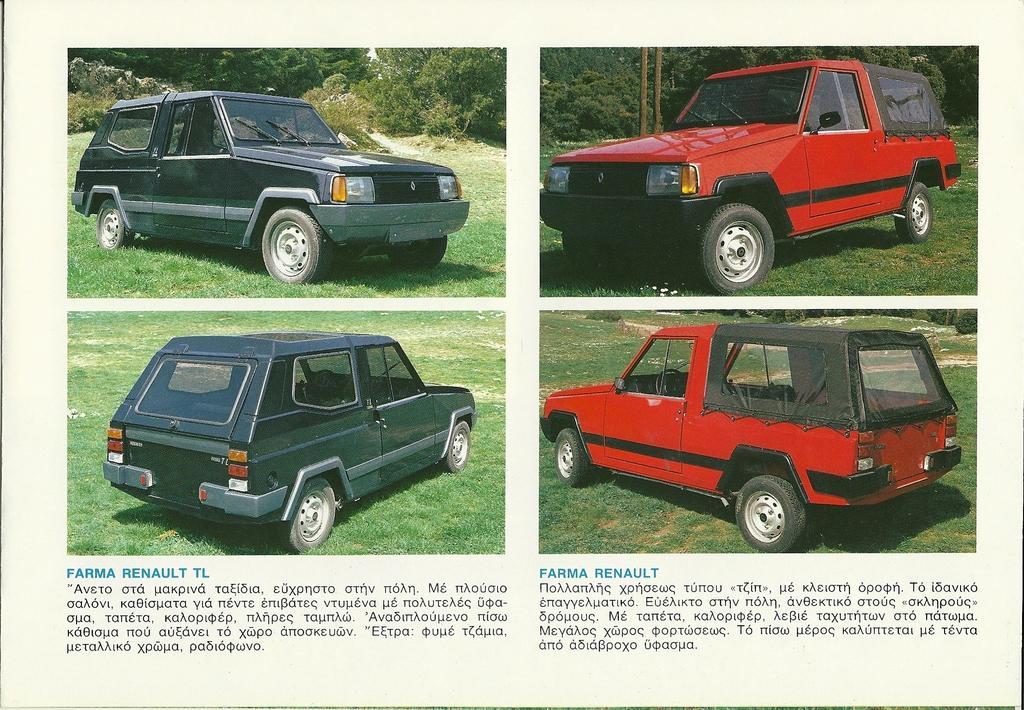Can you describe this image briefly? The picture is collage of images. At the bottom there is text. In this picture there are four cars. The cars are in black and red in color. In the image, at the top there are trees, plants and grass. 